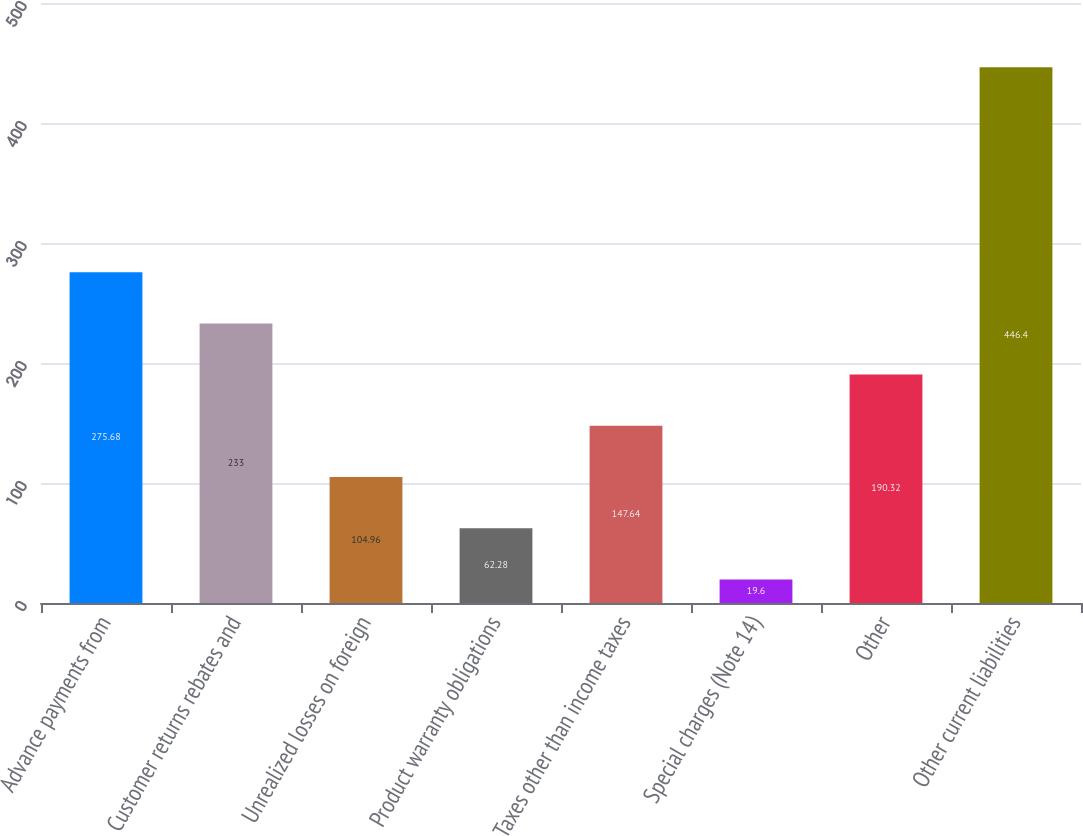<chart> <loc_0><loc_0><loc_500><loc_500><bar_chart><fcel>Advance payments from<fcel>Customer returns rebates and<fcel>Unrealized losses on foreign<fcel>Product warranty obligations<fcel>Taxes other than income taxes<fcel>Special charges (Note 14)<fcel>Other<fcel>Other current liabilities<nl><fcel>275.68<fcel>233<fcel>104.96<fcel>62.28<fcel>147.64<fcel>19.6<fcel>190.32<fcel>446.4<nl></chart> 